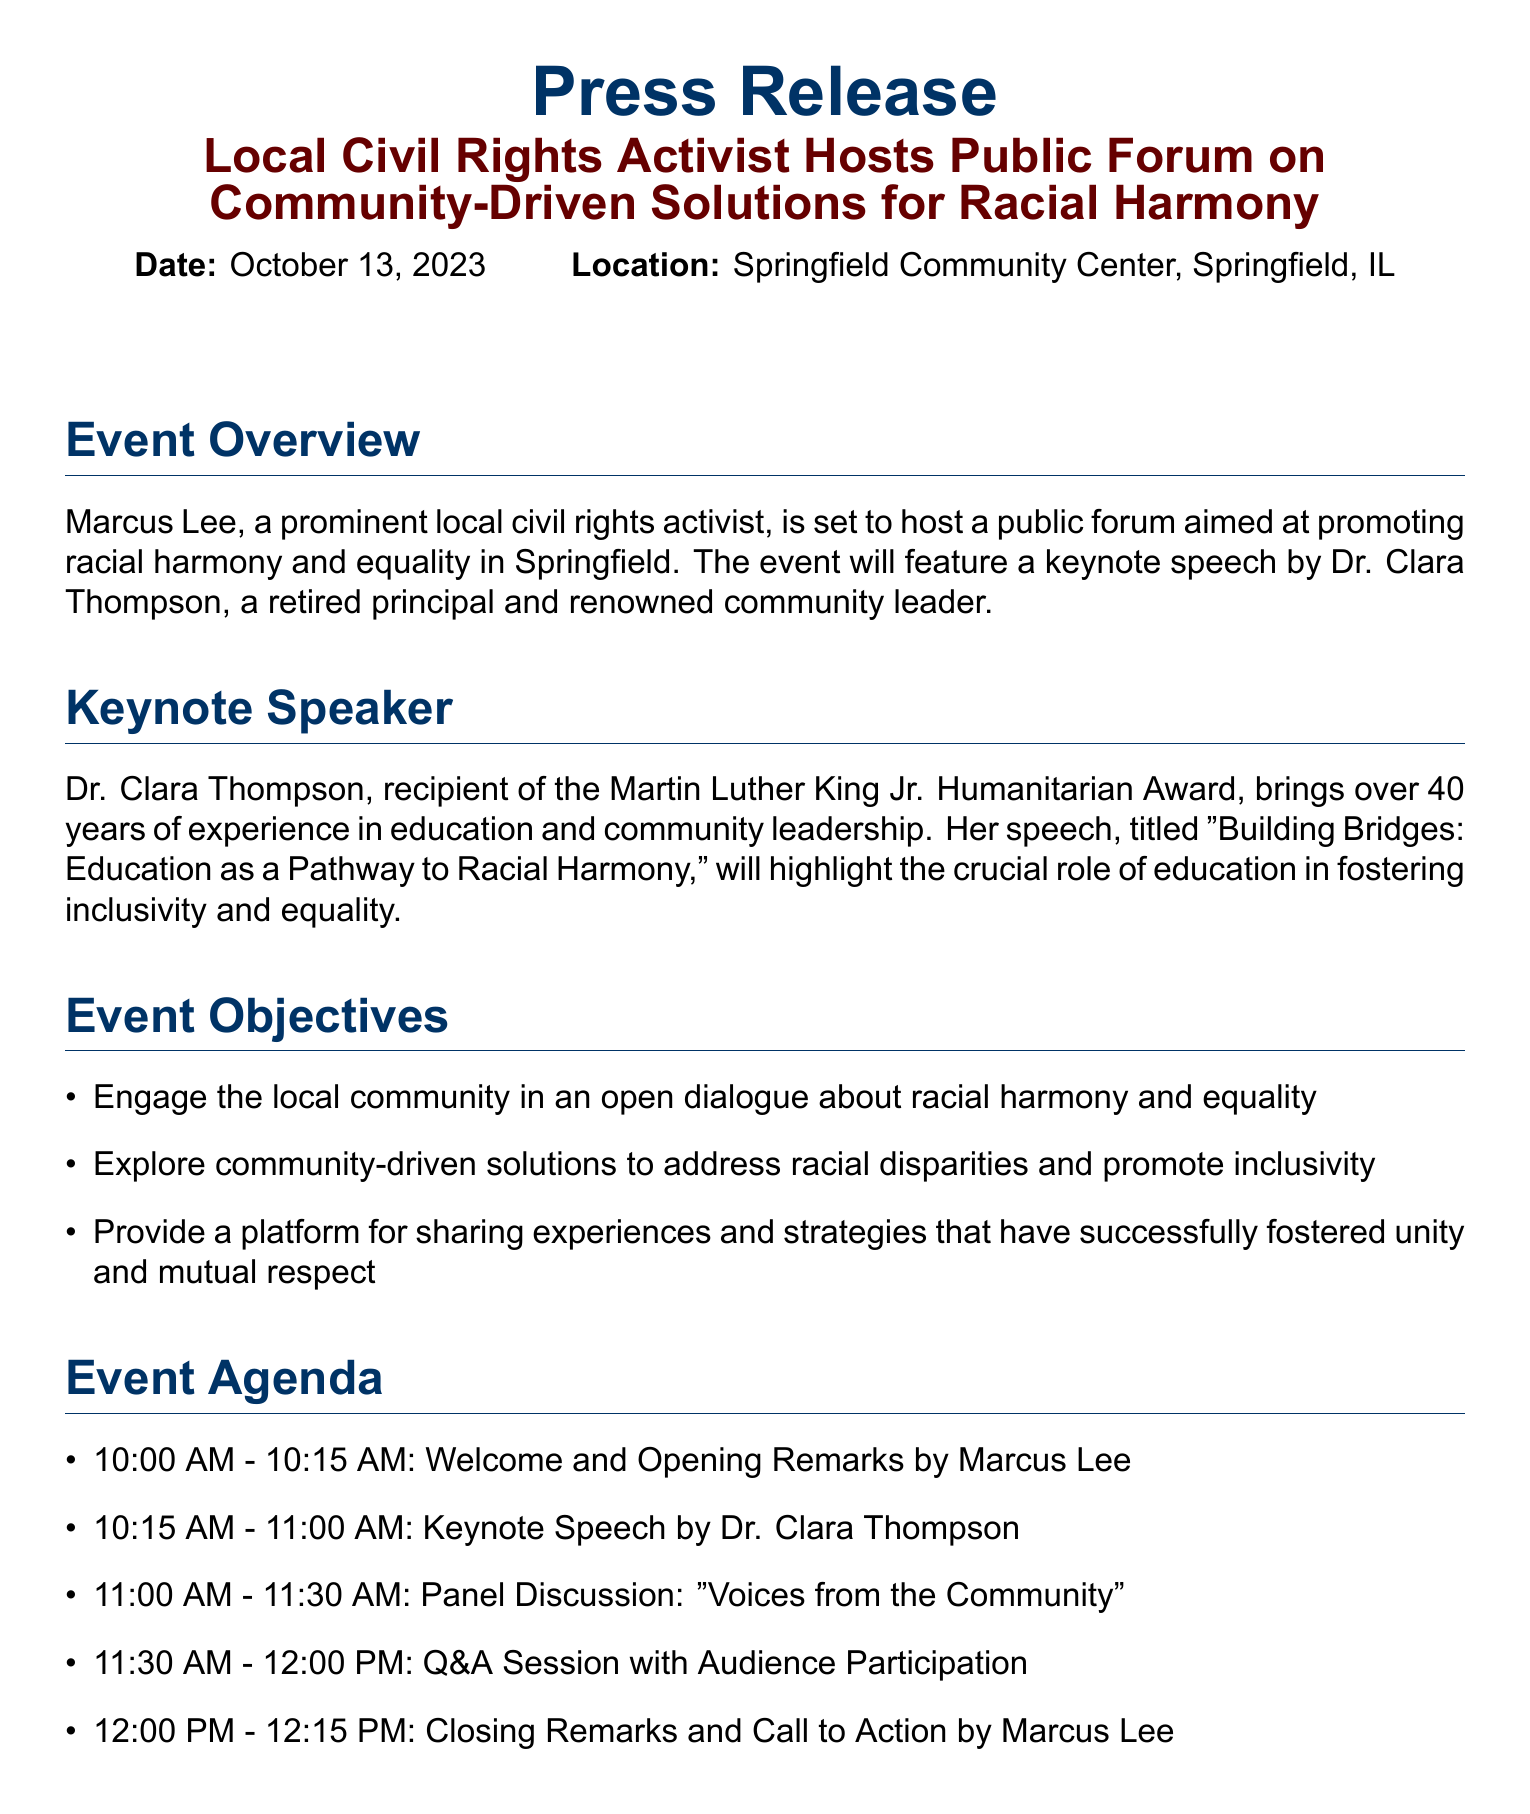What is the date of the event? The date of the event is clearly stated in the document under the heading "Date."
Answer: October 13, 2023 Who is the keynote speaker? The keynote speaker is mentioned in the "Keynote Speaker" section of the document.
Answer: Dr. Clara Thompson What is the title of the keynote speech? The title of the speech is provided in the "Keynote Speaker" section.
Answer: Building Bridges: Education as a Pathway to Racial Harmony How long is the panel discussion scheduled for? The duration of the panel discussion can be found in the "Event Agenda" section.
Answer: 30 minutes What organization hosted the forum? The host of the forum is stated at the beginning of the document.
Answer: Marcus Lee What is one objective of the event? Objectives are listed in the "Event Objectives" section of the document.
Answer: Engage the local community in an open dialogue What award has Dr. Clara Thompson received? The award received by Dr. Clara Thompson is mentioned in the "Keynote Speaker" section.
Answer: Martin Luther King Jr. Humanitarian Award At what time does the event start? The start time of the event is indicated in the "Event Agenda" section.
Answer: 10:00 AM What is one quote attributed to Marcus Lee? A quote by Marcus Lee is provided towards the end of the document.
Answer: "We must come together as a community to address the pervasive issue of racial inequality." 